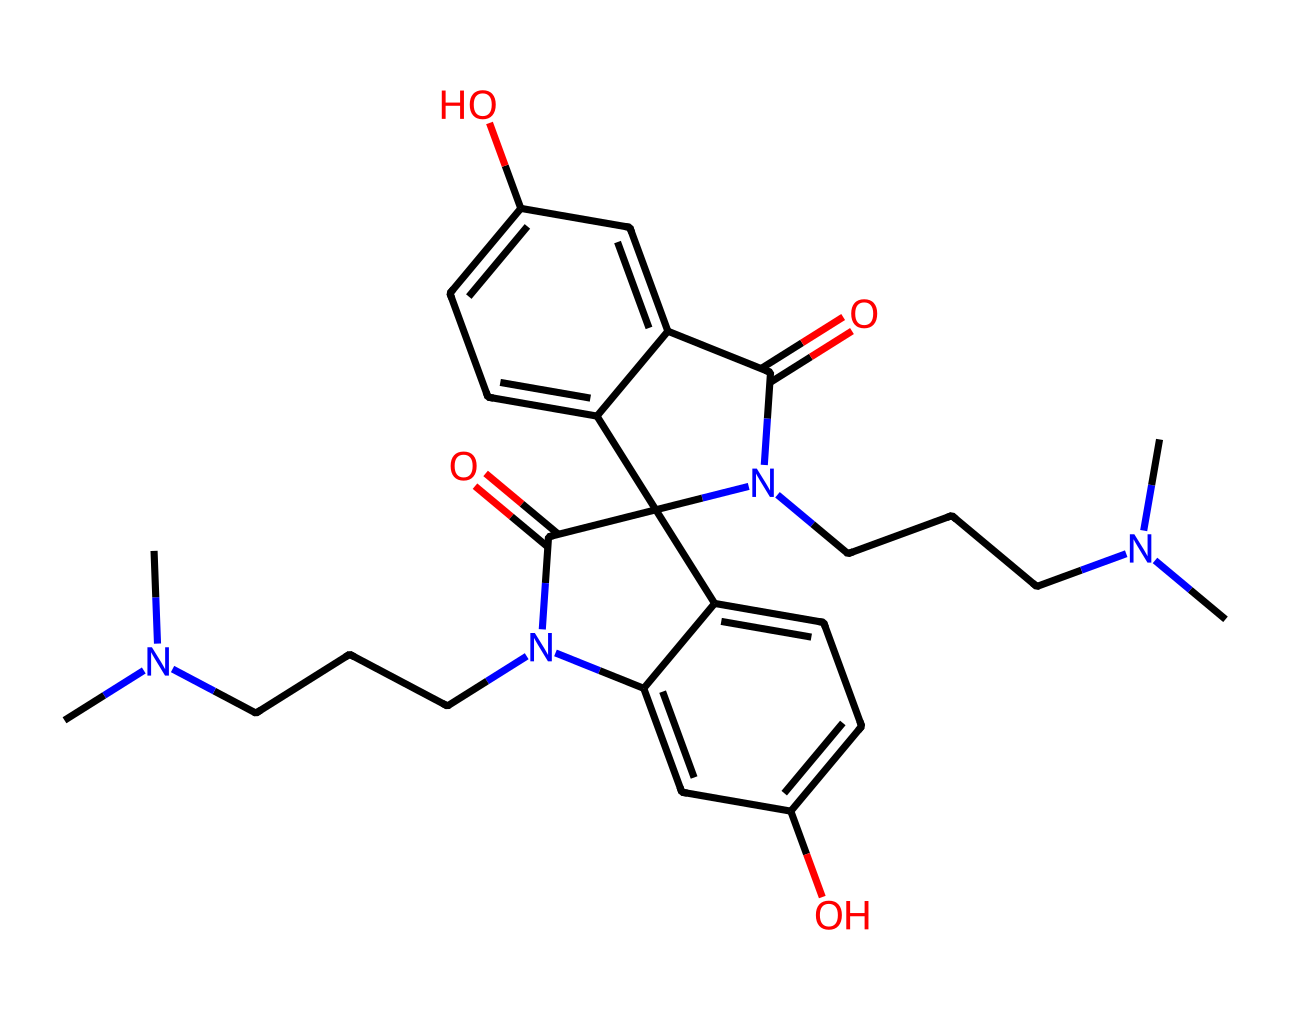What is the total number of nitrogen atoms in this chemical structure? The SMILES representation includes 'N', which denotes nitrogen atoms. Counting them, we find two nitrogen atoms present in the structure.
Answer: two How many hydroxyl (-OH) groups are present in this chemical? In the SMILES representation, the 'O' before 'cc' indicates the presence of hydroxyl groups. There are two occurrences of "O" in the structure relating to hydroxyl, signifying two hydroxyl groups.
Answer: two Identify the type of bonding that indicates the presence of aromatic rings in this chemical. The presence of 'c' in the SMILES denotes aromatic carbon atoms. By analyzing the connections among them, we can conclude that this compound contains multiple aromatic rings due to several adjacent 'c'-based bonds.
Answer: aromatic Is this chemical likely to fluoresce under UV light? Why? The presence of multiple conjugated systems, often signaled by alternating double bonds and aromatic rings in its structure, suggests that it can absorb certain wavelengths of light, causing fluorescence under UV light.
Answer: yes What type of chemical classification does this compound belong to? This compound is characterized by its ability to react to light, which typically identifies it as a photoreactive chemical. Given the structure and presence of nitrogen and oxygen, it also falls under the category of organic compounds.
Answer: photoreactive chemical 